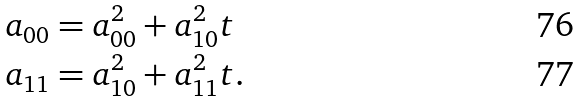<formula> <loc_0><loc_0><loc_500><loc_500>a _ { 0 0 } & = a _ { 0 0 } ^ { 2 } + a _ { 1 0 } ^ { 2 } t \\ a _ { 1 1 } & = a _ { 1 0 } ^ { 2 } + a _ { 1 1 } ^ { 2 } t .</formula> 